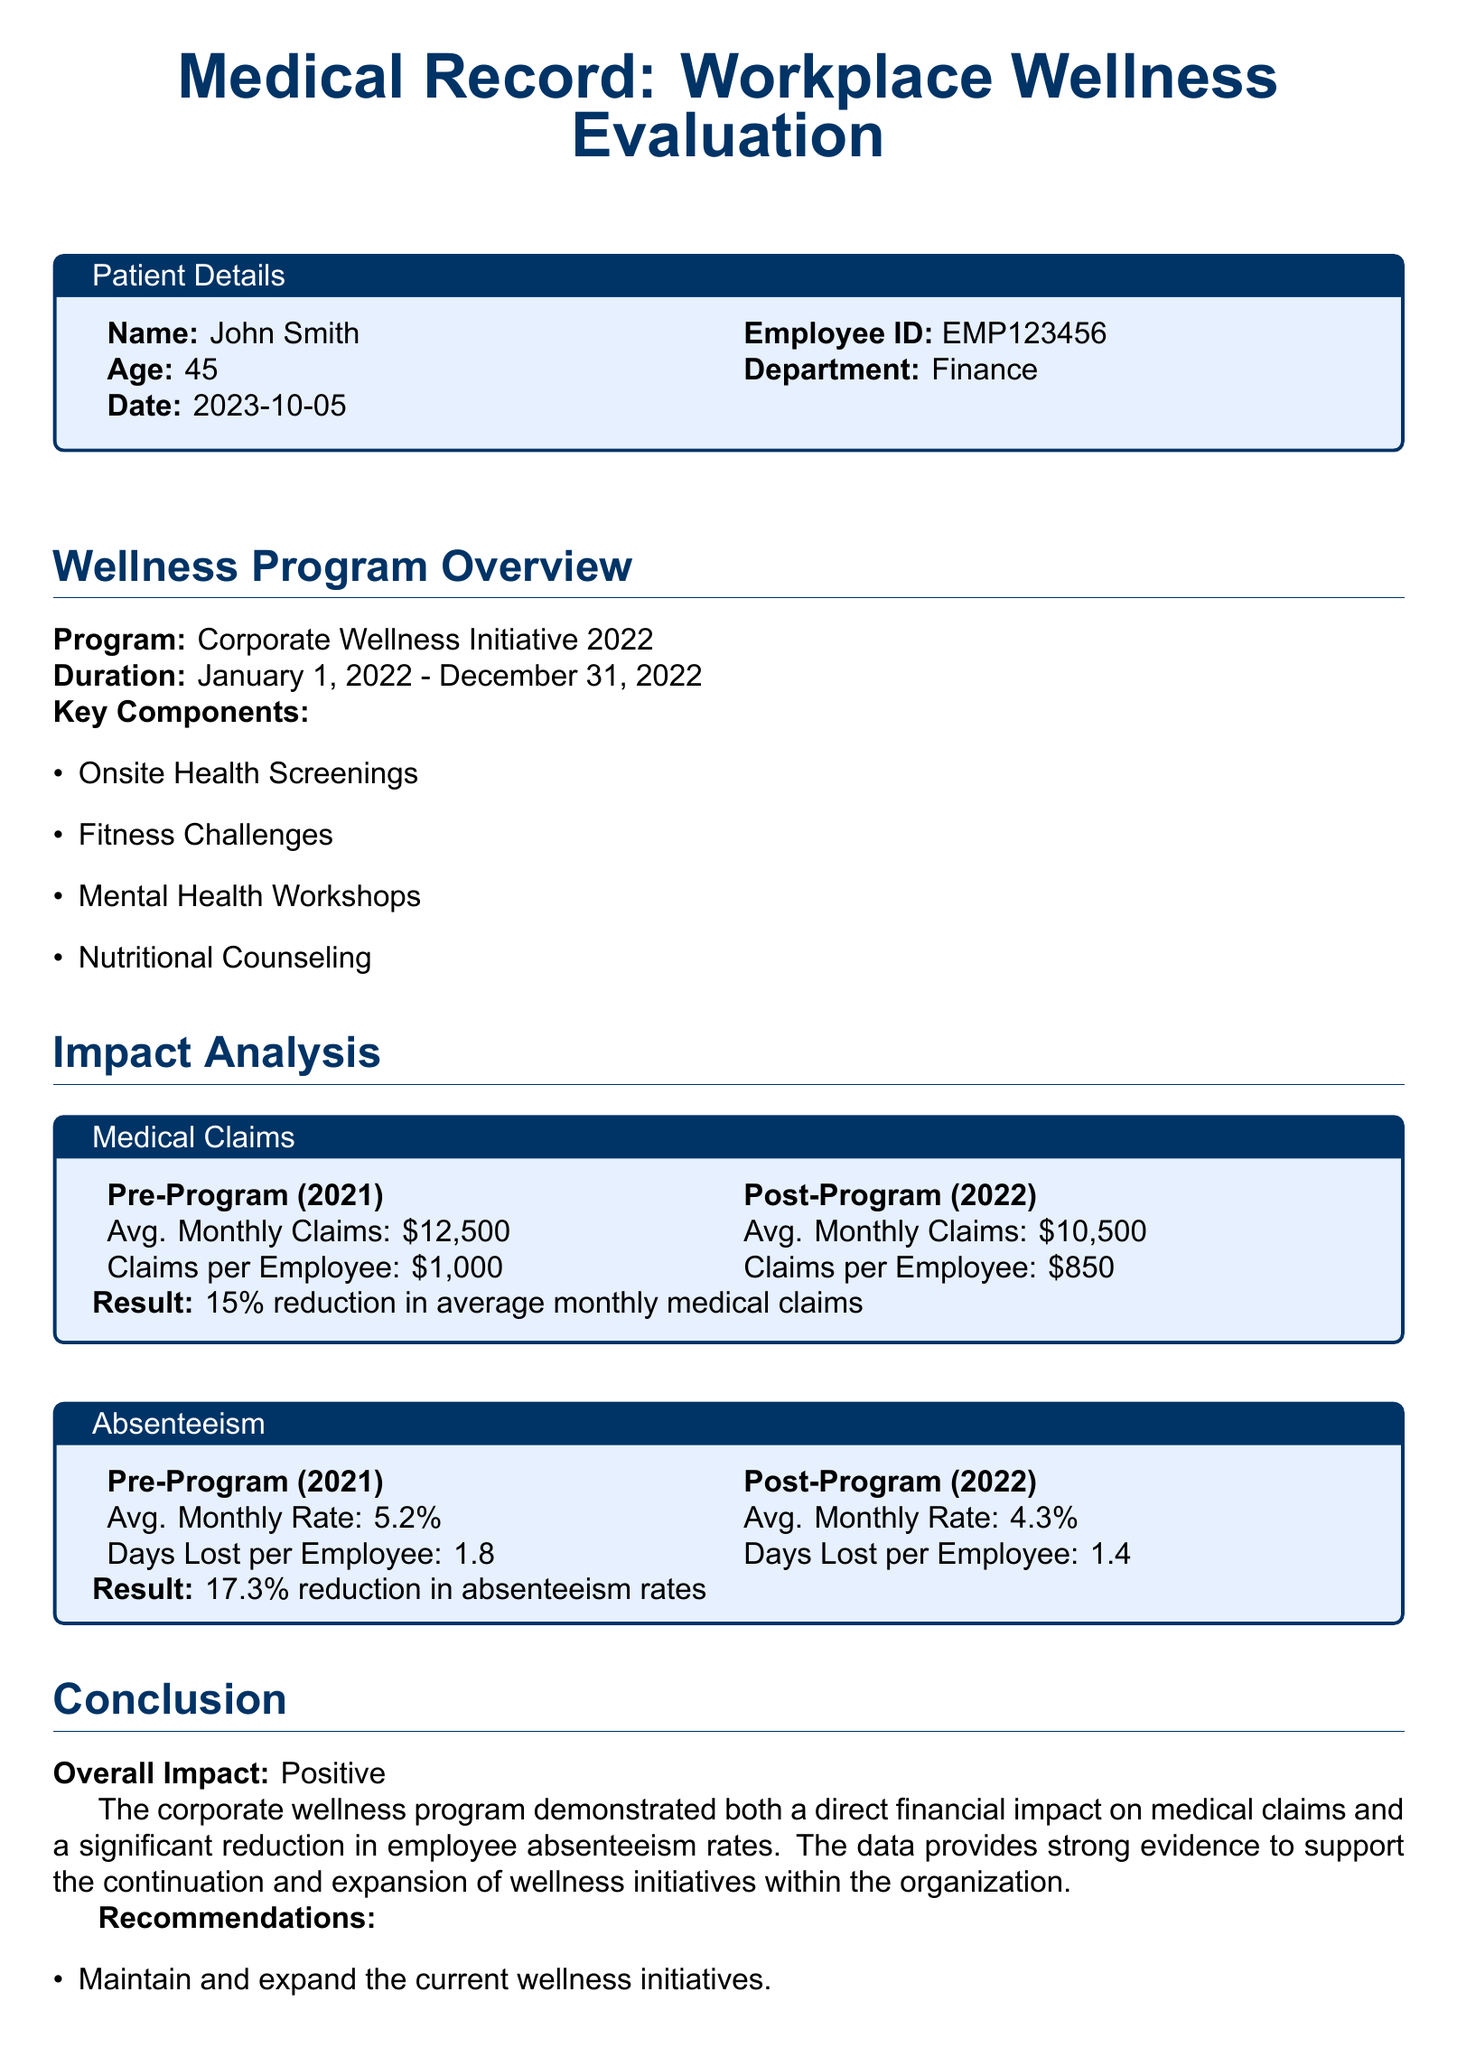What is the name of the employee? The name of the employee is mentioned in the patient details section of the document.
Answer: John Smith What was the duration of the Corporate Wellness Initiative? The document specifies the start and end date of the wellness program under the Wellness Program Overview section.
Answer: January 1, 2022 - December 31, 2022 What was the average monthly claim before the program? This figure is represented in the medical claims section comparing pre-program and post-program statistics.
Answer: $12,500 What percentage reduction was observed in absenteeism rates? The document states the reduction percentage for absenteeism rates in the Impact Analysis section.
Answer: 17.3% What type of workshops was conducted as part of the wellness program? The wellness program overview mentions different components of the initiative, including types of workshops.
Answer: Mental Health Workshops What was the average monthly claims per employee post-program? The average claims per employee after the program is stated in the medical claims table.
Answer: $850 What is the average days lost per employee pre-program? This information is found in the absenteeism section, comparing past and current metrics.
Answer: 1.8 What is the conclusion of the impact analysis? The conclusion summarizes the overall impact of the wellness program as listed in the document.
Answer: Positive 